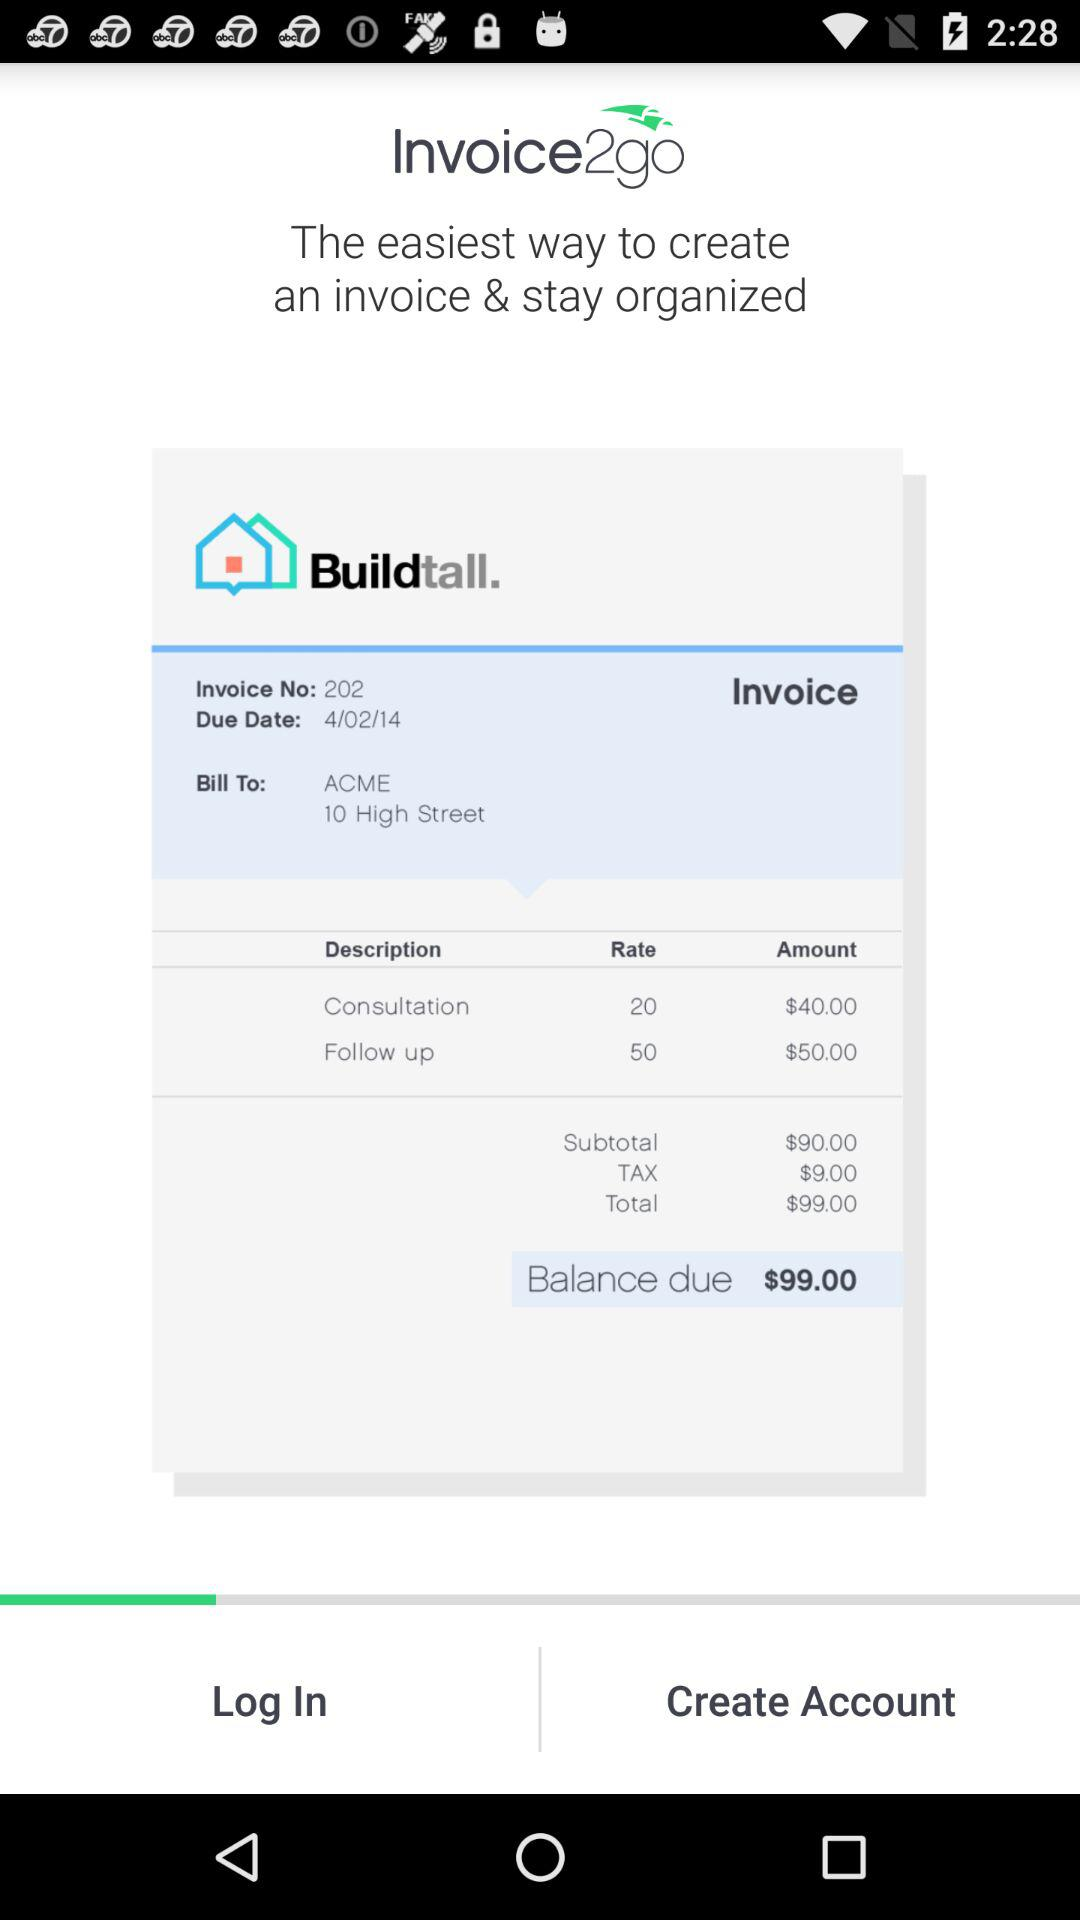What is the total amount due on this invoice?
Answer the question using a single word or phrase. $99.00 